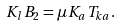<formula> <loc_0><loc_0><loc_500><loc_500>K _ { l } B _ { 2 } = \mu K _ { a } T _ { k a } .</formula> 